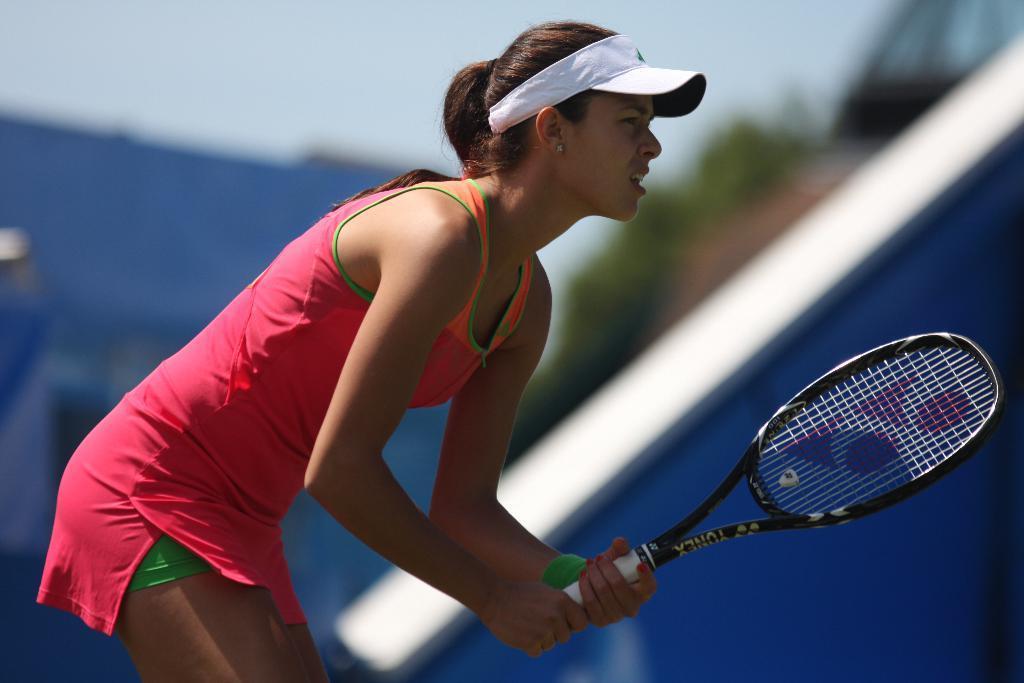How would you summarize this image in a sentence or two? In the picture there is a woman standing, she is holding a tennis bat she is wearing a white color hat and pink color dress,in the background there is a tennis court and sky. 